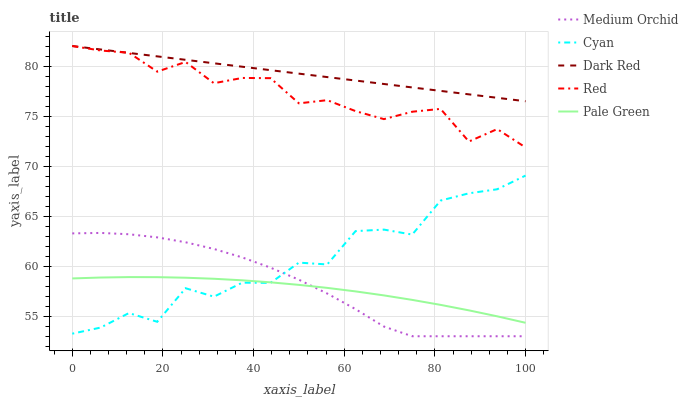Does Pale Green have the minimum area under the curve?
Answer yes or no. Yes. Does Dark Red have the maximum area under the curve?
Answer yes or no. Yes. Does Medium Orchid have the minimum area under the curve?
Answer yes or no. No. Does Medium Orchid have the maximum area under the curve?
Answer yes or no. No. Is Dark Red the smoothest?
Answer yes or no. Yes. Is Cyan the roughest?
Answer yes or no. Yes. Is Pale Green the smoothest?
Answer yes or no. No. Is Pale Green the roughest?
Answer yes or no. No. Does Pale Green have the lowest value?
Answer yes or no. No. Does Dark Red have the highest value?
Answer yes or no. Yes. Does Medium Orchid have the highest value?
Answer yes or no. No. Is Medium Orchid less than Red?
Answer yes or no. Yes. Is Dark Red greater than Pale Green?
Answer yes or no. Yes. Does Red intersect Dark Red?
Answer yes or no. Yes. Is Red less than Dark Red?
Answer yes or no. No. Is Red greater than Dark Red?
Answer yes or no. No. Does Medium Orchid intersect Red?
Answer yes or no. No. 